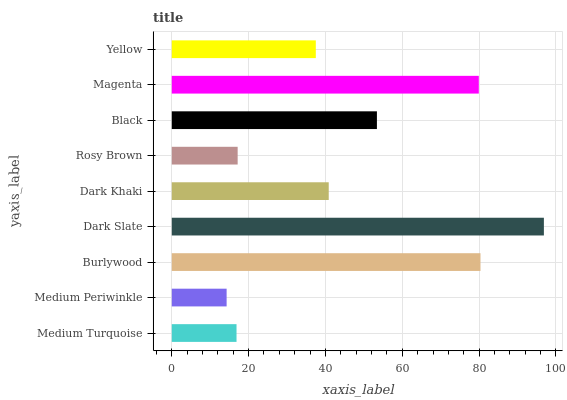Is Medium Periwinkle the minimum?
Answer yes or no. Yes. Is Dark Slate the maximum?
Answer yes or no. Yes. Is Burlywood the minimum?
Answer yes or no. No. Is Burlywood the maximum?
Answer yes or no. No. Is Burlywood greater than Medium Periwinkle?
Answer yes or no. Yes. Is Medium Periwinkle less than Burlywood?
Answer yes or no. Yes. Is Medium Periwinkle greater than Burlywood?
Answer yes or no. No. Is Burlywood less than Medium Periwinkle?
Answer yes or no. No. Is Dark Khaki the high median?
Answer yes or no. Yes. Is Dark Khaki the low median?
Answer yes or no. Yes. Is Magenta the high median?
Answer yes or no. No. Is Dark Slate the low median?
Answer yes or no. No. 